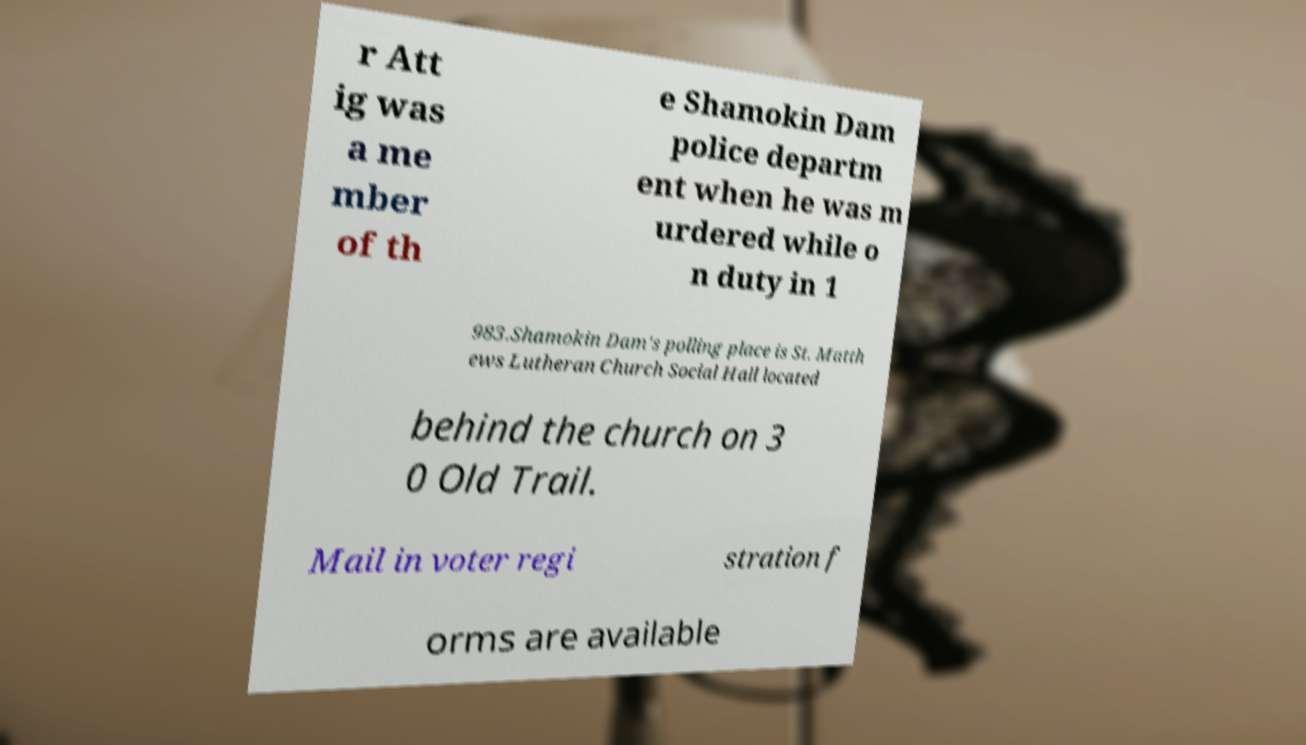Could you extract and type out the text from this image? r Att ig was a me mber of th e Shamokin Dam police departm ent when he was m urdered while o n duty in 1 983.Shamokin Dam's polling place is St. Matth ews Lutheran Church Social Hall located behind the church on 3 0 Old Trail. Mail in voter regi stration f orms are available 